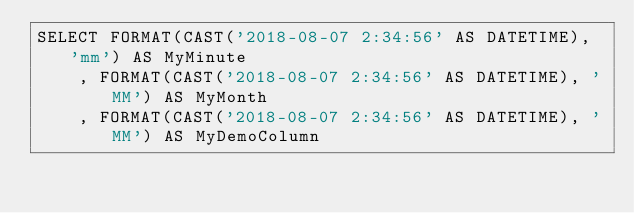<code> <loc_0><loc_0><loc_500><loc_500><_SQL_>SELECT FORMAT(CAST('2018-08-07 2:34:56' AS DATETIME), 'mm') AS MyMinute
	, FORMAT(CAST('2018-08-07 2:34:56' AS DATETIME), 'MM') AS MyMonth
	, FORMAT(CAST('2018-08-07 2:34:56' AS DATETIME), 'MM') AS MyDemoColumn

</code> 